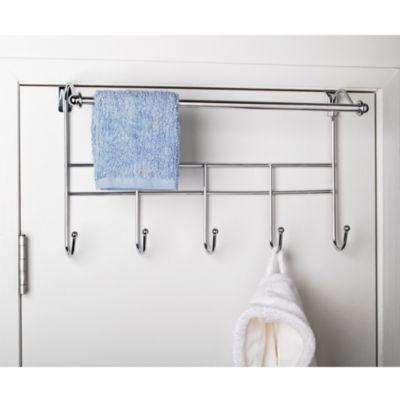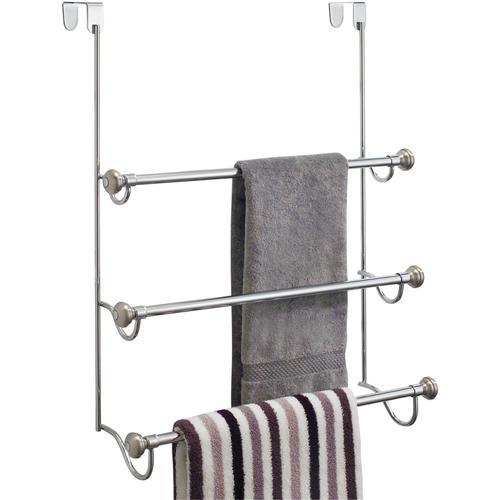The first image is the image on the left, the second image is the image on the right. Analyze the images presented: Is the assertion "There is a blue towel hanging on an over the door rack" valid? Answer yes or no. Yes. The first image is the image on the left, the second image is the image on the right. For the images shown, is this caption "An image shows a light blue towel hanging on an over-the-door rack." true? Answer yes or no. Yes. 